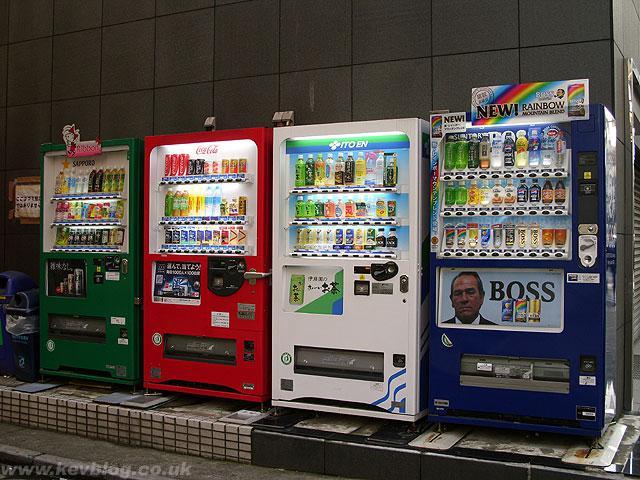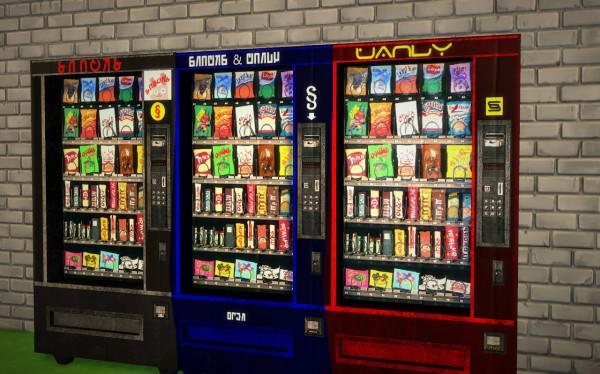The first image is the image on the left, the second image is the image on the right. For the images shown, is this caption "One image shows a horizontal row of exactly three vending machines, with none more than about a foot apart." true? Answer yes or no. Yes. The first image is the image on the left, the second image is the image on the right. Assess this claim about the two images: "In at least one of the images, at least three vending machines are shown in three unique colors including blue and red.". Correct or not? Answer yes or no. Yes. 